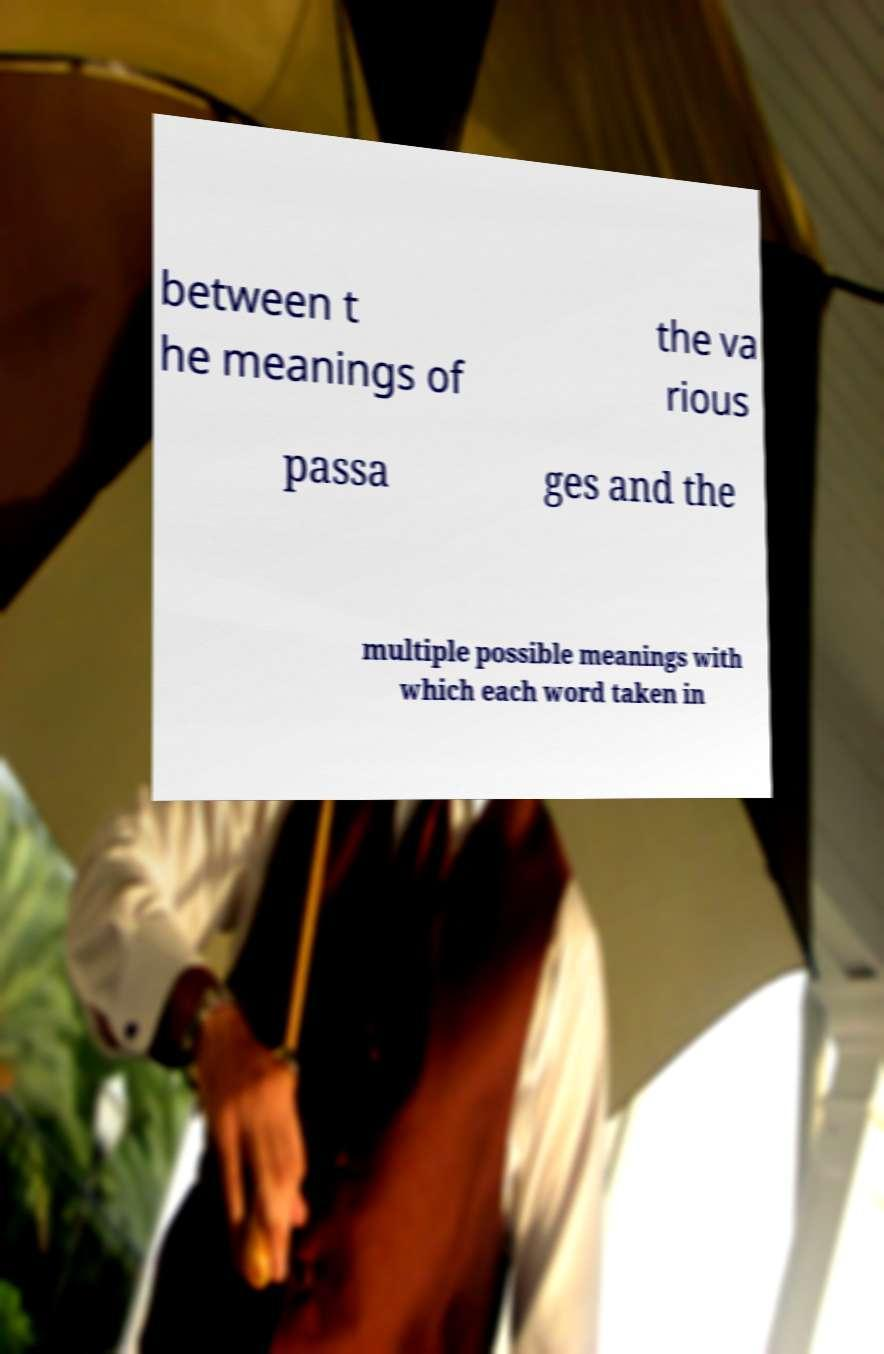For documentation purposes, I need the text within this image transcribed. Could you provide that? between t he meanings of the va rious passa ges and the multiple possible meanings with which each word taken in 